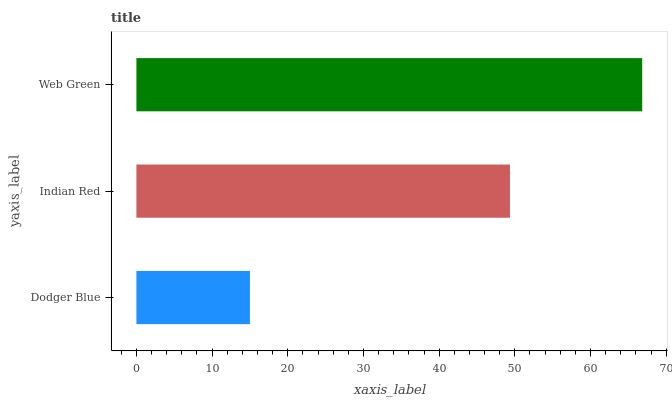Is Dodger Blue the minimum?
Answer yes or no. Yes. Is Web Green the maximum?
Answer yes or no. Yes. Is Indian Red the minimum?
Answer yes or no. No. Is Indian Red the maximum?
Answer yes or no. No. Is Indian Red greater than Dodger Blue?
Answer yes or no. Yes. Is Dodger Blue less than Indian Red?
Answer yes or no. Yes. Is Dodger Blue greater than Indian Red?
Answer yes or no. No. Is Indian Red less than Dodger Blue?
Answer yes or no. No. Is Indian Red the high median?
Answer yes or no. Yes. Is Indian Red the low median?
Answer yes or no. Yes. Is Web Green the high median?
Answer yes or no. No. Is Web Green the low median?
Answer yes or no. No. 